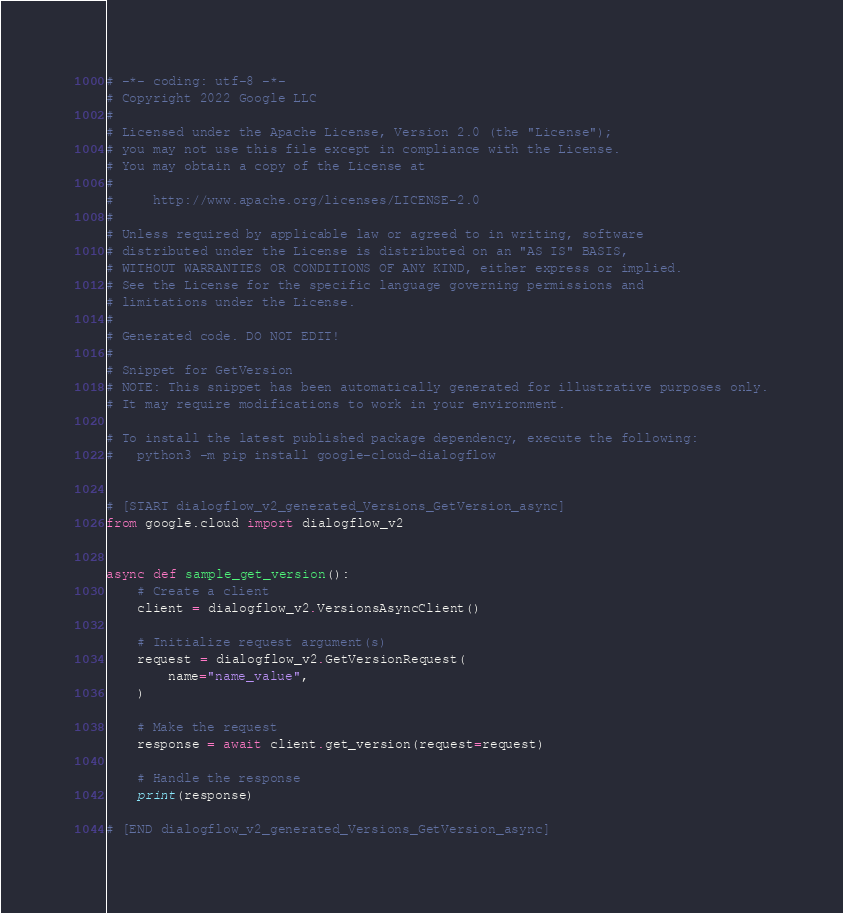<code> <loc_0><loc_0><loc_500><loc_500><_Python_># -*- coding: utf-8 -*-
# Copyright 2022 Google LLC
#
# Licensed under the Apache License, Version 2.0 (the "License");
# you may not use this file except in compliance with the License.
# You may obtain a copy of the License at
#
#     http://www.apache.org/licenses/LICENSE-2.0
#
# Unless required by applicable law or agreed to in writing, software
# distributed under the License is distributed on an "AS IS" BASIS,
# WITHOUT WARRANTIES OR CONDITIONS OF ANY KIND, either express or implied.
# See the License for the specific language governing permissions and
# limitations under the License.
#
# Generated code. DO NOT EDIT!
#
# Snippet for GetVersion
# NOTE: This snippet has been automatically generated for illustrative purposes only.
# It may require modifications to work in your environment.

# To install the latest published package dependency, execute the following:
#   python3 -m pip install google-cloud-dialogflow


# [START dialogflow_v2_generated_Versions_GetVersion_async]
from google.cloud import dialogflow_v2


async def sample_get_version():
    # Create a client
    client = dialogflow_v2.VersionsAsyncClient()

    # Initialize request argument(s)
    request = dialogflow_v2.GetVersionRequest(
        name="name_value",
    )

    # Make the request
    response = await client.get_version(request=request)

    # Handle the response
    print(response)

# [END dialogflow_v2_generated_Versions_GetVersion_async]
</code> 